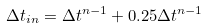<formula> <loc_0><loc_0><loc_500><loc_500>\Delta t _ { i n } = \Delta t ^ { n - 1 } + 0 . 2 5 \Delta t ^ { n - 1 }</formula> 